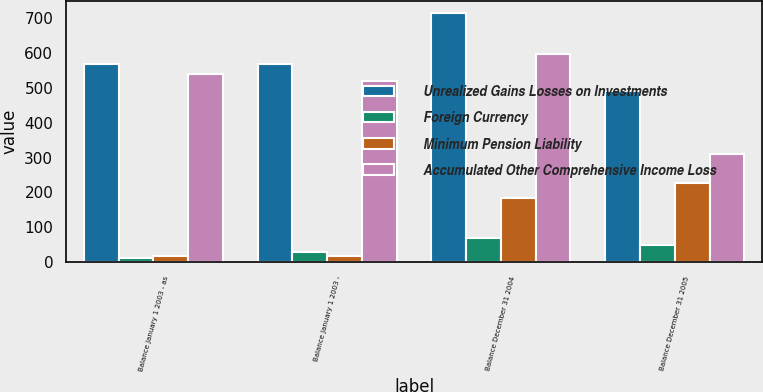Convert chart to OTSL. <chart><loc_0><loc_0><loc_500><loc_500><stacked_bar_chart><ecel><fcel>Balance January 1 2003 - as<fcel>Balance January 1 2003 -<fcel>Balance December 31 2004<fcel>Balance December 31 2005<nl><fcel>Unrealized Gains Losses on Investments<fcel>567.6<fcel>567.6<fcel>712.8<fcel>489.4<nl><fcel>Foreign Currency<fcel>11.6<fcel>29.5<fcel>69.3<fcel>48.5<nl><fcel>Minimum Pension Liability<fcel>17.7<fcel>17.7<fcel>184.7<fcel>226.8<nl><fcel>Accumulated Other Comprehensive Income Loss<fcel>538.3<fcel>520.4<fcel>597.4<fcel>311.1<nl></chart> 